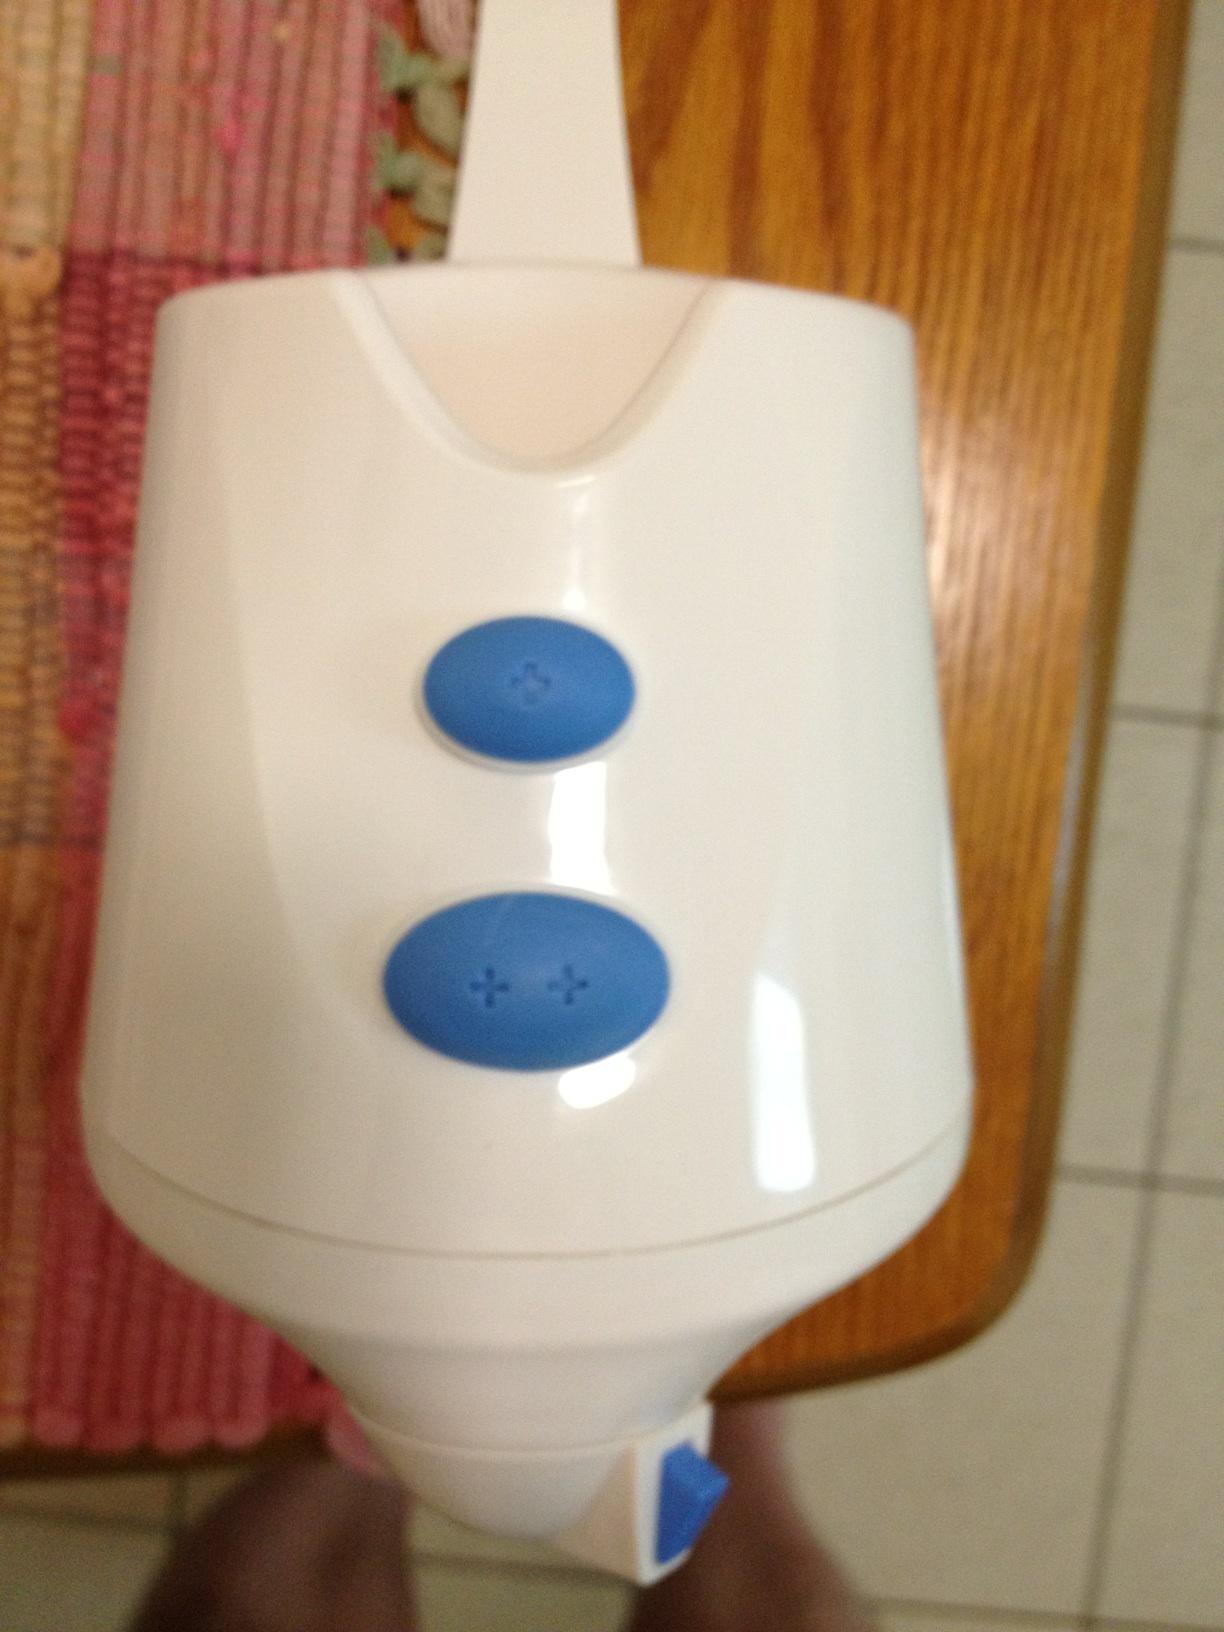Create a detailed scenario in which this device plays a crucial role. Emily is hosting a dinner party for her friends, and time is of the essence. She uses this multifunctional device to whip up sauces and mix batter for desserts, adjusting the settings with utmost precision using the plus-sign buttons. As the evening progresses, she seamlessly switches between settings to blend cocktails and puree soups, impressing her guests with the ease and efficiency of her cooking. This device becomes an unsung hero of the evening, ensuring everything runs smoothly and efficiently. 